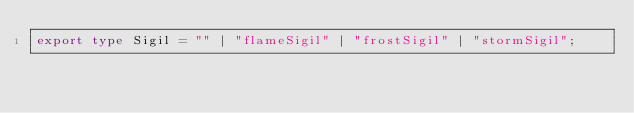<code> <loc_0><loc_0><loc_500><loc_500><_TypeScript_>export type Sigil = "" | "flameSigil" | "frostSigil" | "stormSigil";
</code> 